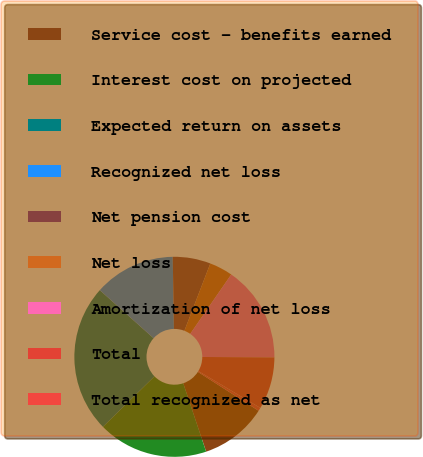<chart> <loc_0><loc_0><loc_500><loc_500><pie_chart><fcel>Service cost - benefits earned<fcel>Interest cost on projected<fcel>Expected return on assets<fcel>Recognized net loss<fcel>Net pension cost<fcel>Net loss<fcel>Amortization of net loss<fcel>Total<fcel>Total recognized as net<nl><fcel>10.79%<fcel>17.81%<fcel>23.94%<fcel>13.13%<fcel>6.11%<fcel>3.77%<fcel>15.47%<fcel>8.45%<fcel>0.53%<nl></chart> 